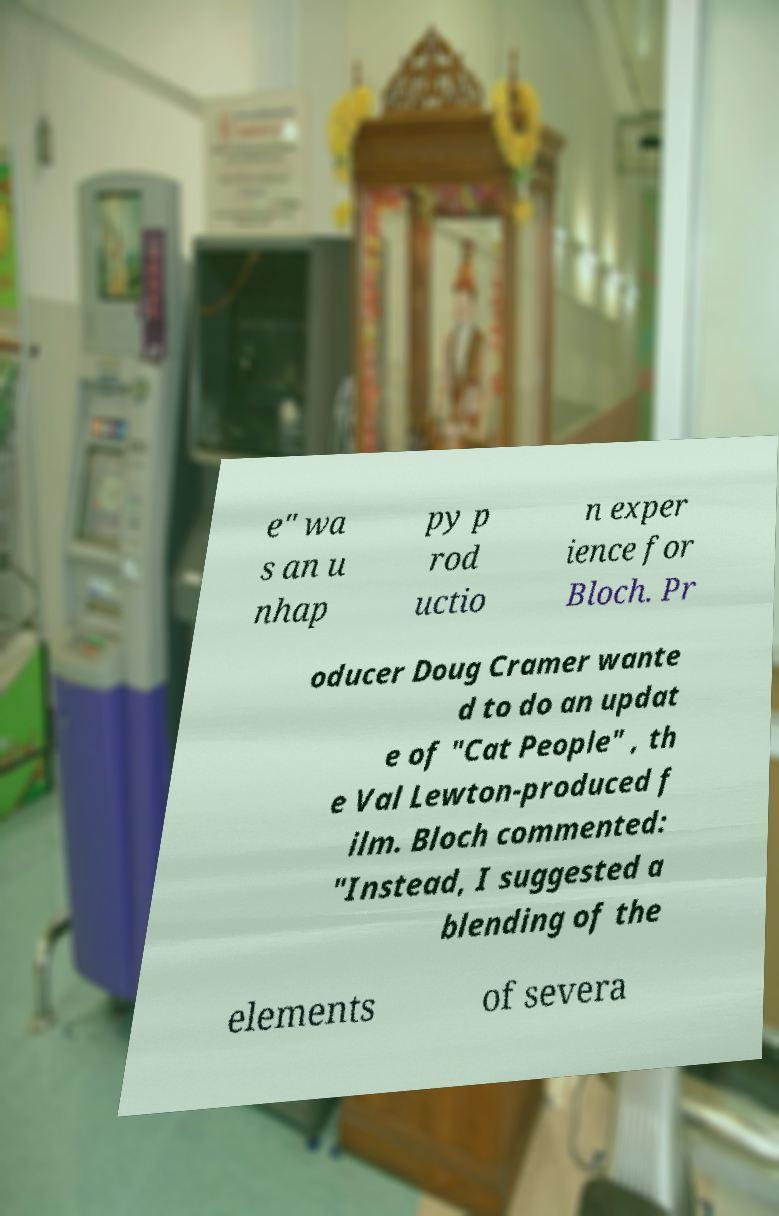Could you extract and type out the text from this image? e" wa s an u nhap py p rod uctio n exper ience for Bloch. Pr oducer Doug Cramer wante d to do an updat e of "Cat People" , th e Val Lewton-produced f ilm. Bloch commented: "Instead, I suggested a blending of the elements of severa 